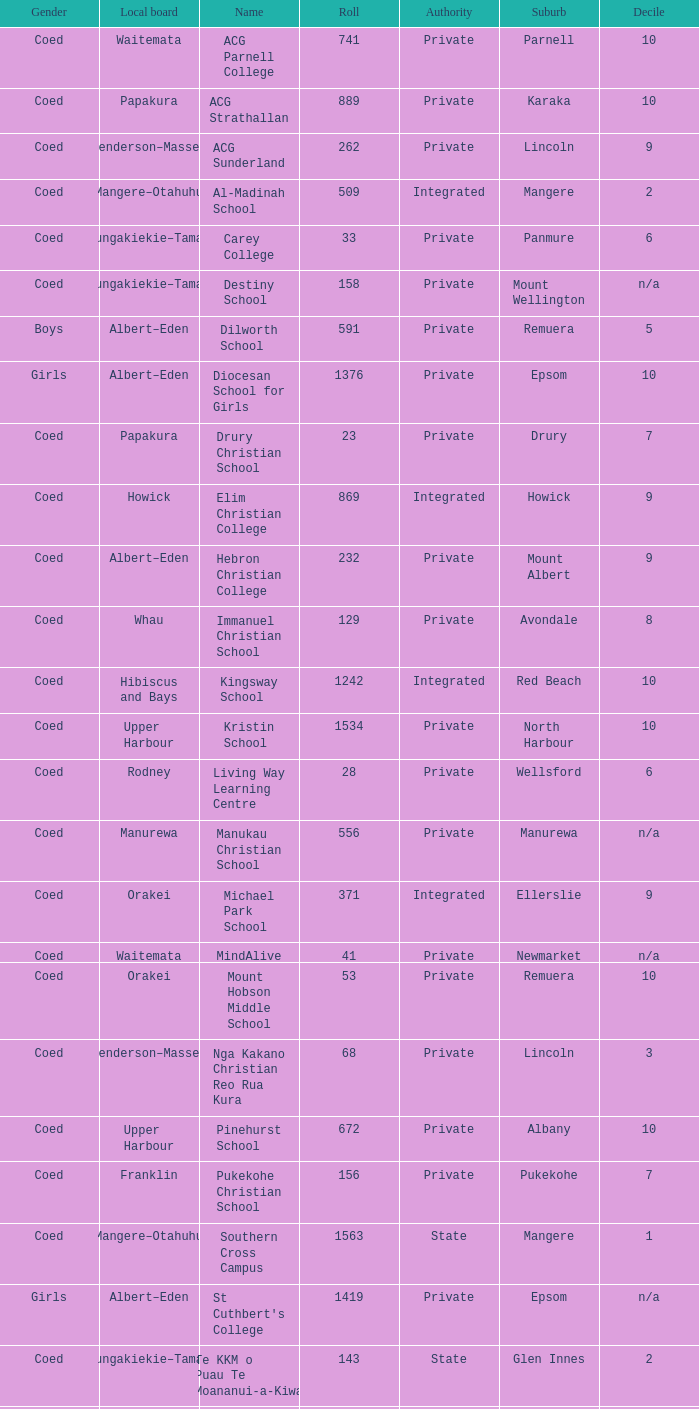What gender has a local board of albert–eden with a roll of more than 232 and Decile of 5? Boys. Could you help me parse every detail presented in this table? {'header': ['Gender', 'Local board', 'Name', 'Roll', 'Authority', 'Suburb', 'Decile'], 'rows': [['Coed', 'Waitemata', 'ACG Parnell College', '741', 'Private', 'Parnell', '10'], ['Coed', 'Papakura', 'ACG Strathallan', '889', 'Private', 'Karaka', '10'], ['Coed', 'Henderson–Massey', 'ACG Sunderland', '262', 'Private', 'Lincoln', '9'], ['Coed', 'Mangere–Otahuhu', 'Al-Madinah School', '509', 'Integrated', 'Mangere', '2'], ['Coed', 'Maungakiekie–Tamaki', 'Carey College', '33', 'Private', 'Panmure', '6'], ['Coed', 'Maungakiekie–Tamaki', 'Destiny School', '158', 'Private', 'Mount Wellington', 'n/a'], ['Boys', 'Albert–Eden', 'Dilworth School', '591', 'Private', 'Remuera', '5'], ['Girls', 'Albert–Eden', 'Diocesan School for Girls', '1376', 'Private', 'Epsom', '10'], ['Coed', 'Papakura', 'Drury Christian School', '23', 'Private', 'Drury', '7'], ['Coed', 'Howick', 'Elim Christian College', '869', 'Integrated', 'Howick', '9'], ['Coed', 'Albert–Eden', 'Hebron Christian College', '232', 'Private', 'Mount Albert', '9'], ['Coed', 'Whau', 'Immanuel Christian School', '129', 'Private', 'Avondale', '8'], ['Coed', 'Hibiscus and Bays', 'Kingsway School', '1242', 'Integrated', 'Red Beach', '10'], ['Coed', 'Upper Harbour', 'Kristin School', '1534', 'Private', 'North Harbour', '10'], ['Coed', 'Rodney', 'Living Way Learning Centre', '28', 'Private', 'Wellsford', '6'], ['Coed', 'Manurewa', 'Manukau Christian School', '556', 'Private', 'Manurewa', 'n/a'], ['Coed', 'Orakei', 'Michael Park School', '371', 'Integrated', 'Ellerslie', '9'], ['Coed', 'Waitemata', 'MindAlive', '41', 'Private', 'Newmarket', 'n/a'], ['Coed', 'Orakei', 'Mount Hobson Middle School', '53', 'Private', 'Remuera', '10'], ['Coed', 'Henderson–Massey', 'Nga Kakano Christian Reo Rua Kura', '68', 'Private', 'Lincoln', '3'], ['Coed', 'Upper Harbour', 'Pinehurst School', '672', 'Private', 'Albany', '10'], ['Coed', 'Franklin', 'Pukekohe Christian School', '156', 'Private', 'Pukekohe', '7'], ['Coed', 'Mangere–Otahuhu', 'Southern Cross Campus', '1563', 'State', 'Mangere', '1'], ['Girls', 'Albert–Eden', "St Cuthbert's College", '1419', 'Private', 'Epsom', 'n/a'], ['Coed', 'Maungakiekie–Tamaki', 'Te KKM o Puau Te Moananui-a-Kiwa', '143', 'State', 'Glen Innes', '2'], ['Coed', 'Mangere–Otahuhu', 'Te Kura Maori o Nga Tapuwae', '281', 'State', 'Mangere', '1'], ['Coed', 'Howick', 'The Bridge Academy', '3', 'Private', 'Howick', 'n/a'], ['Coed', 'Hibiscus and Bays', 'The Corelli School', '46', 'Private', 'Browns Bay', '10'], ['Coed', 'Waitakere Ranges', 'Titirangi Rudolf Steiner School', '158', 'Private', 'Woodlands Park', '9'], ['Coed', 'Waitakere Ranges', 'TKKM o Hoani Waititi', '166', 'State', 'Glen Eden West', '4'], ['Coed', 'Mangere–Otahuhu', 'TKKM o Mangere', '193', 'State', 'Mangere', '2'], ['Coed', 'Upper Harbour', 'TKKM o Te Raki Paewhenua', '76', 'State', 'Windsor Park', '5'], ['Coed', 'Howick', 'Tyndale Park Christian School', '120', 'Private', 'Flat Bush', 'n/a']]} 